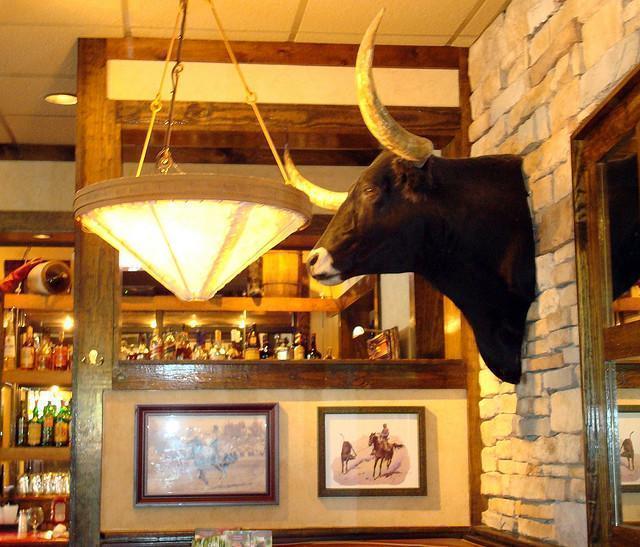What type of facility is displaying the animal head?
Pick the correct solution from the four options below to address the question.
Options: Bar, medical office, hotel, home. Bar. 